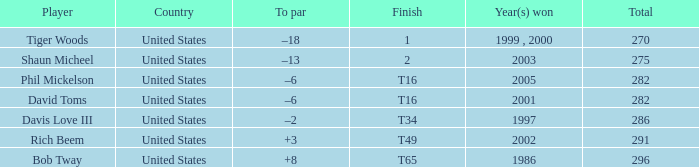What is Davis Love III's total? 286.0. 